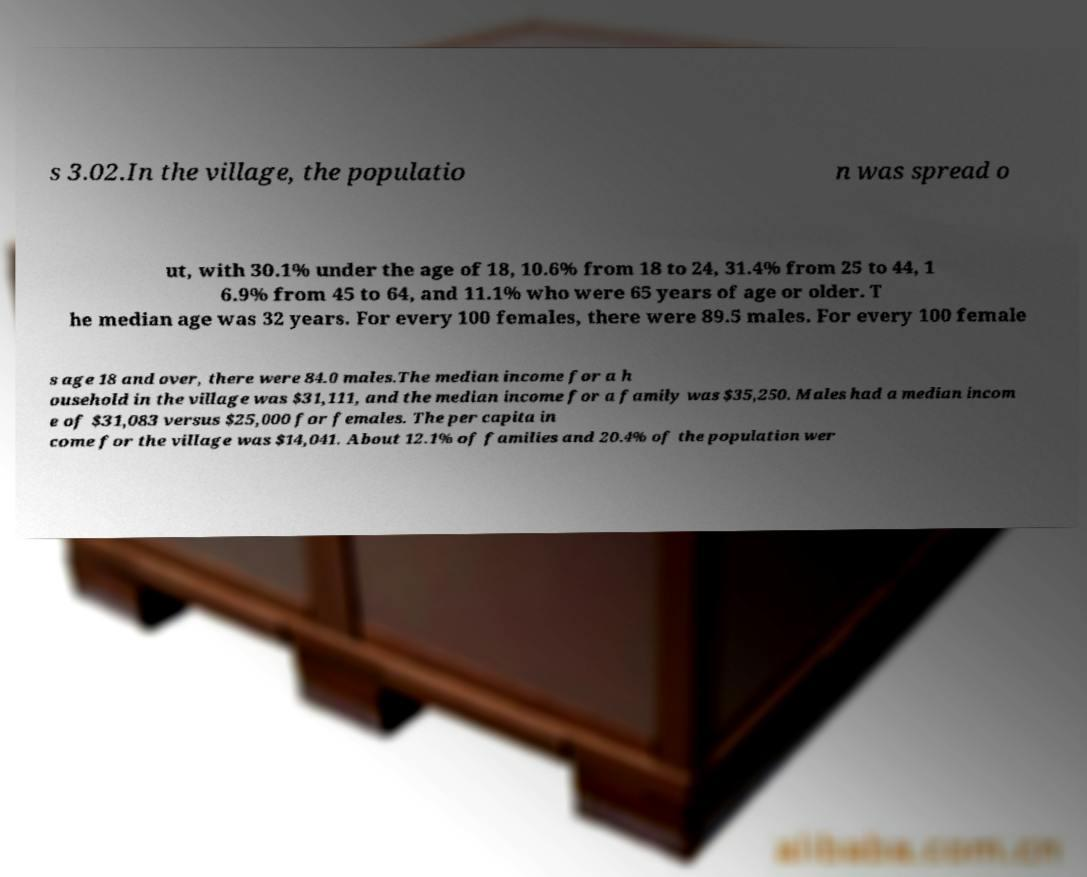Please read and relay the text visible in this image. What does it say? s 3.02.In the village, the populatio n was spread o ut, with 30.1% under the age of 18, 10.6% from 18 to 24, 31.4% from 25 to 44, 1 6.9% from 45 to 64, and 11.1% who were 65 years of age or older. T he median age was 32 years. For every 100 females, there were 89.5 males. For every 100 female s age 18 and over, there were 84.0 males.The median income for a h ousehold in the village was $31,111, and the median income for a family was $35,250. Males had a median incom e of $31,083 versus $25,000 for females. The per capita in come for the village was $14,041. About 12.1% of families and 20.4% of the population wer 